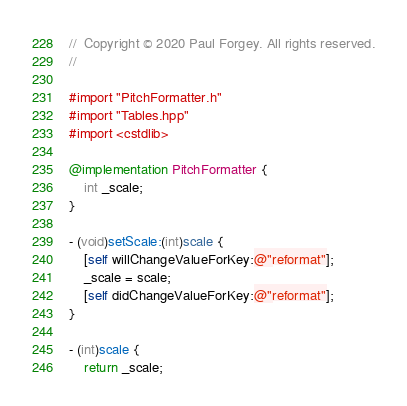Convert code to text. <code><loc_0><loc_0><loc_500><loc_500><_ObjectiveC_>//  Copyright © 2020 Paul Forgey. All rights reserved.
//

#import "PitchFormatter.h"
#import "Tables.hpp"
#import <cstdlib>

@implementation PitchFormatter {
    int _scale;
}

- (void)setScale:(int)scale {
    [self willChangeValueForKey:@"reformat"];
    _scale = scale;
    [self didChangeValueForKey:@"reformat"];
}

- (int)scale {
    return _scale;</code> 